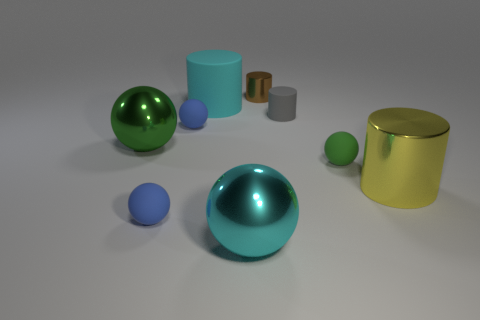Subtract all cyan balls. How many balls are left? 4 Subtract all big green metal balls. How many balls are left? 4 Subtract all gray balls. Subtract all blue cylinders. How many balls are left? 5 Add 1 yellow metallic balls. How many objects exist? 10 Subtract all cylinders. How many objects are left? 5 Subtract all big green objects. Subtract all gray rubber objects. How many objects are left? 7 Add 1 large green metal balls. How many large green metal balls are left? 2 Add 5 small matte balls. How many small matte balls exist? 8 Subtract 0 cyan cubes. How many objects are left? 9 